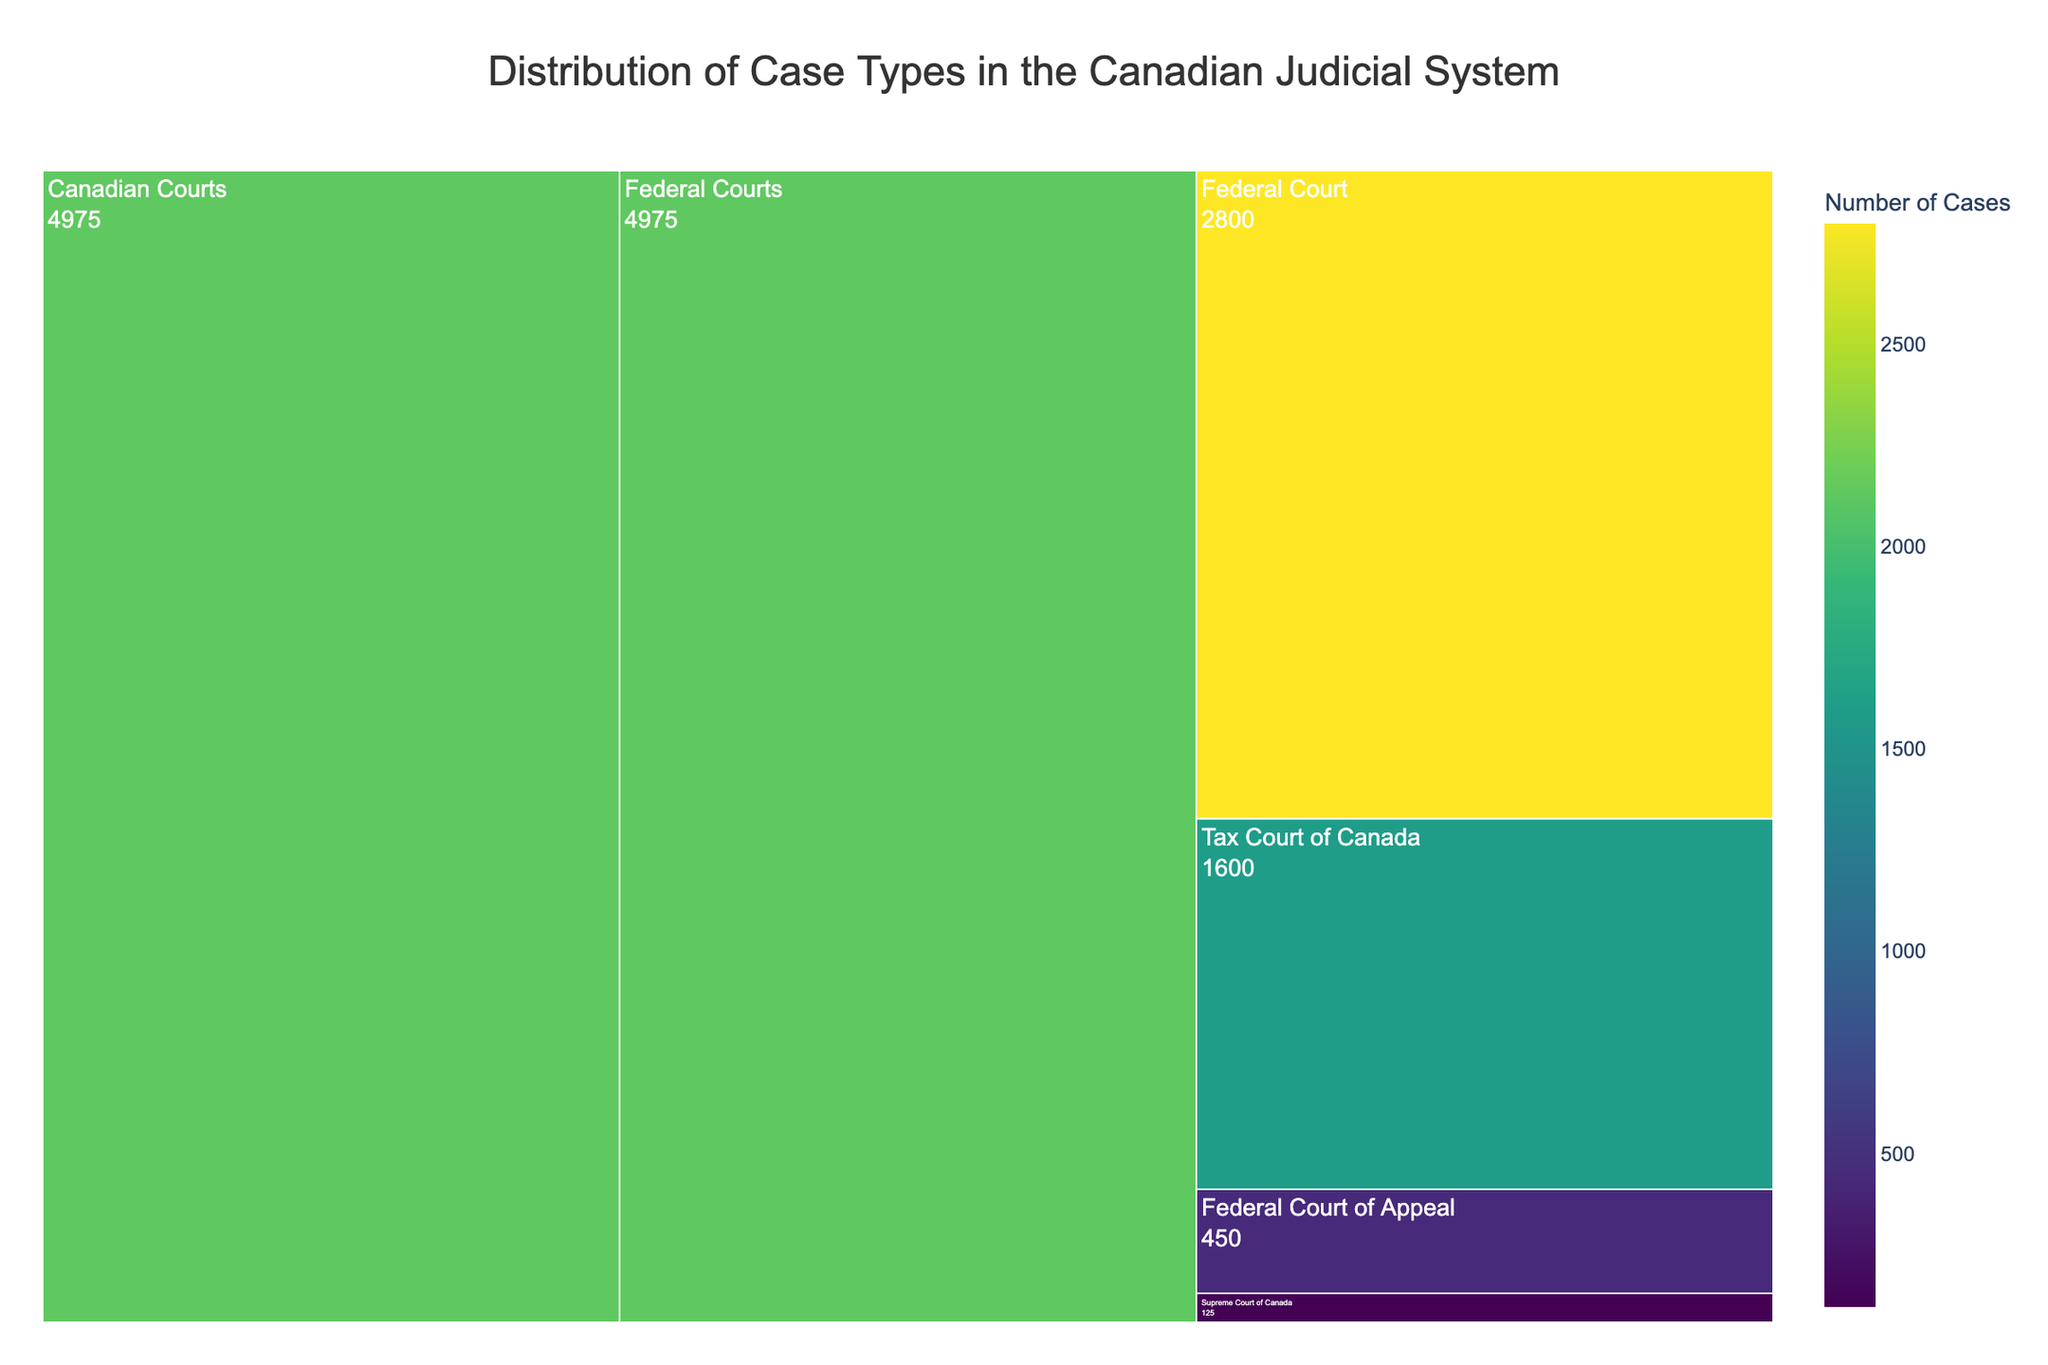What's the title of the figure? The title is typically displayed at the top-center of the plot. Here, it can be seen as "Distribution of Case Types in the Canadian Judicial System".
Answer: Distribution of Case Types in the Canadian Judicial System Which Federal Court has the highest number of cases? Observing the values associated with each Federal Court subcategory, the Federal Court has the highest number of cases at 2800.
Answer: Federal Court How many total cases are represented in the Federal Courts category? Summing the values for each Federal Court: Supreme Court of Canada (125) + Federal Court of Appeal (450) + Federal Court (2800) + Tax Court of Canada (1600), which equals 4975.
Answer: 4975 Which court handles more cases: the Tax Court of Canada or the Federal Court of Appeal? Comparing the values for the Tax Court of Canada (1600) and the Federal Court of Appeal (450), it is clear that the Tax Court of Canada handles more cases.
Answer: Tax Court of Canada What proportion of the total Federal Court cases does the Supreme Court of Canada handle? The proportion can be calculated as (Supreme Court of Canada cases / Total Federal Court cases) * 100, which is (125 / 4975) * 100 ≈ 2.51%.
Answer: ~2.51% Which court has the smallest number of cases? By comparing the values, the Supreme Court of Canada, with 125 cases, has the smallest number.
Answer: Supreme Court of Canada Rank the Federal Courts from the one with the fewest cases to the most. The ranks can be determined by comparing the values directly: Supreme Court of Canada (125), Federal Court of Appeal (450), Tax Court of Canada (1600), and Federal Court (2800).
Answer: Supreme Court of Canada, Federal Court of Appeal, Tax Court of Canada, Federal Court If the Tax Court of Canada's cases were to increase by 50%, how many cases would it then handle? Increasing the Tax Court of Canada's cases by 50% is calculated by multiplying the current value (1600) by 1.50, resulting in 2400 cases.
Answer: 2400 cases What is the average number of cases per Federal Court? The average is calculated by summing all cases and dividing by the number of courts: (125+450+2800+1600)/4 = 4975/4 = 1243.75.
Answer: 1243.75 If 10% of the Federal Court's cases were moved to the Supreme Court of Canada, how many cases would each then handle? Moving 10% of the Federal Court's cases (2800 * 0.10 = 280) to the Supreme Court of Canada (125): Supreme Court of Canada will have 125 + 280 = 405, and the Federal Court will have 2800 - 280 = 2520.
Answer: Supreme Court of Canada: 405, Federal Court: 2520 